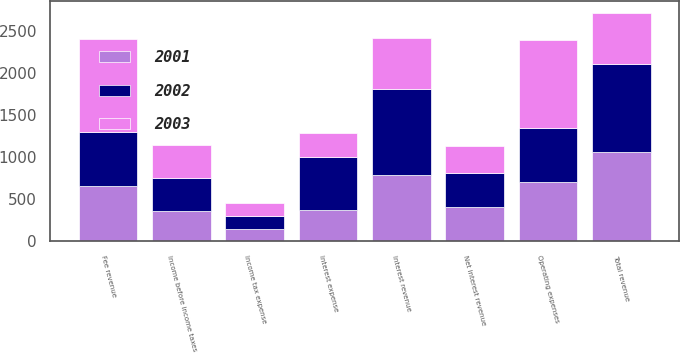Convert chart to OTSL. <chart><loc_0><loc_0><loc_500><loc_500><stacked_bar_chart><ecel><fcel>Fee revenue<fcel>Interest revenue<fcel>Interest expense<fcel>Net interest revenue<fcel>Total revenue<fcel>Operating expenses<fcel>Income before income taxes<fcel>Income tax expense<nl><fcel>2003<fcel>1111<fcel>612<fcel>288<fcel>324<fcel>612<fcel>1045<fcel>390<fcel>146<nl><fcel>2001<fcel>654<fcel>786<fcel>375<fcel>411<fcel>1065<fcel>704<fcel>361<fcel>145<nl><fcel>2002<fcel>642<fcel>1023<fcel>622<fcel>401<fcel>1043<fcel>648<fcel>395<fcel>158<nl></chart> 